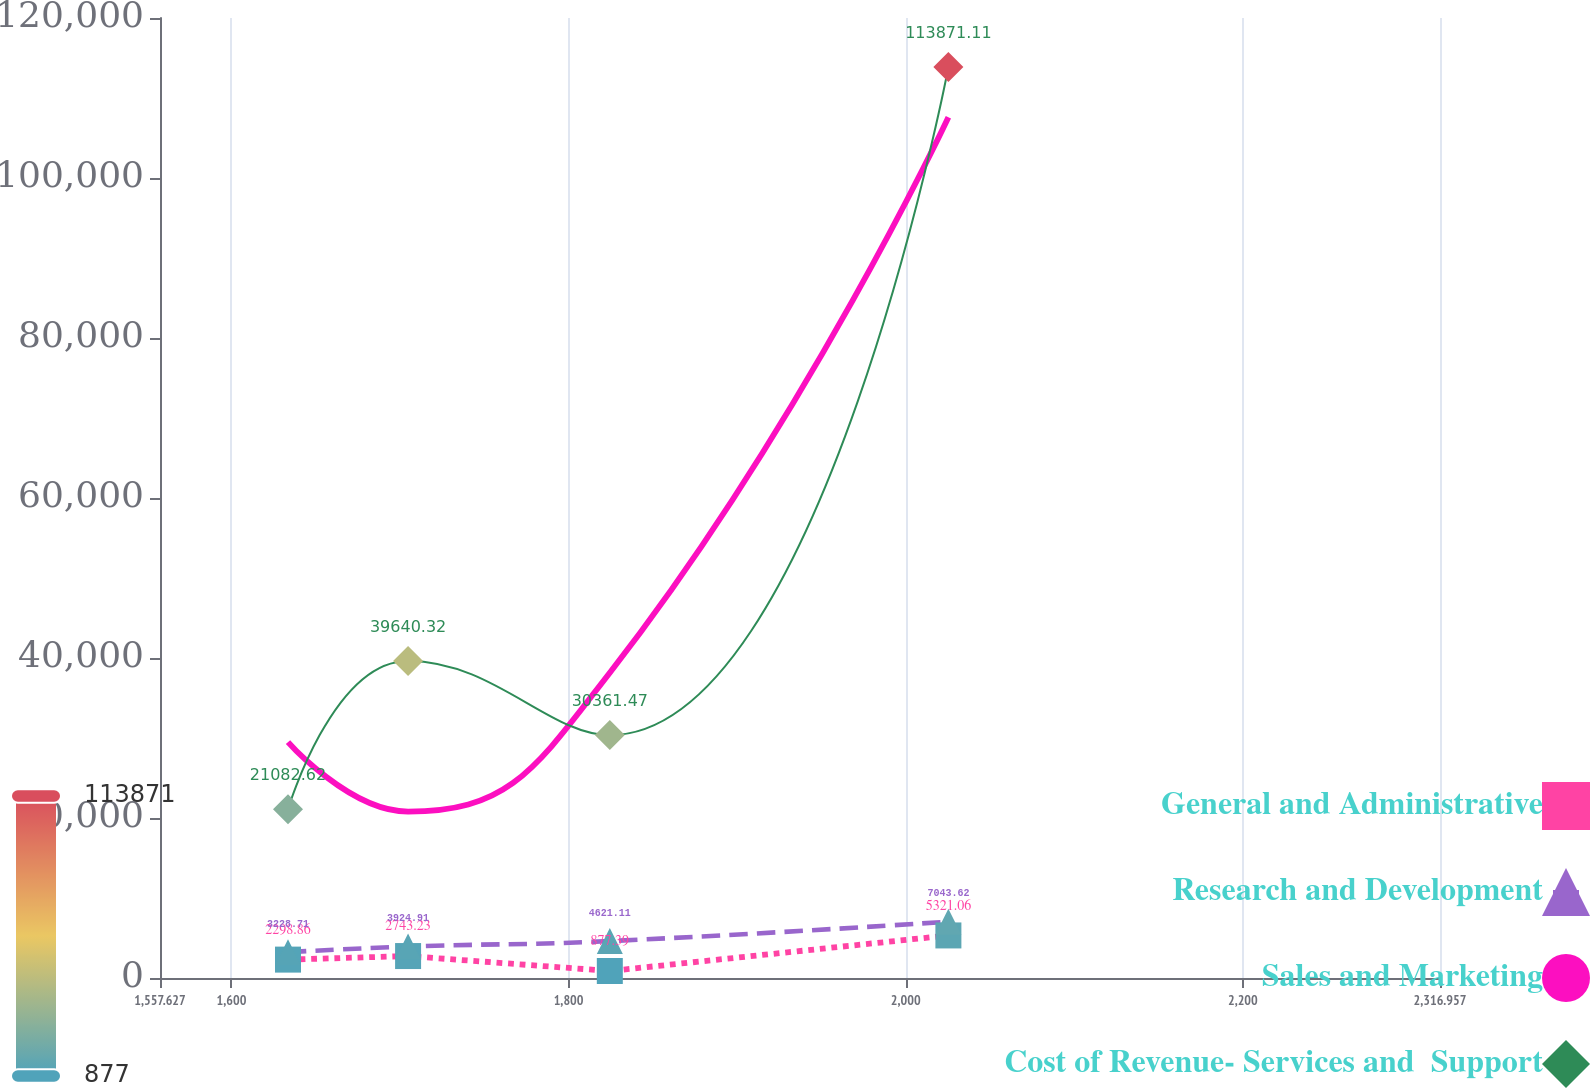<chart> <loc_0><loc_0><loc_500><loc_500><line_chart><ecel><fcel>General and Administrative<fcel>Research and Development<fcel>Sales and Marketing<fcel>Cost of Revenue- Services and  Support<nl><fcel>1633.56<fcel>2298.86<fcel>3228.71<fcel>29476<fcel>21082.6<nl><fcel>1704.8<fcel>2743.23<fcel>3924.91<fcel>20797.2<fcel>39640.3<nl><fcel>1824.47<fcel>877.39<fcel>4621.11<fcel>38154.7<fcel>30361.5<nl><fcel>2025.32<fcel>5321.06<fcel>7043.62<fcel>107585<fcel>113871<nl><fcel>2321.93<fcel>3315.58<fcel>10732.6<fcel>87672.8<fcel>74407.6<nl><fcel>2392.89<fcel>1632.54<fcel>10036.4<fcel>78779.3<fcel>65128.7<nl></chart> 